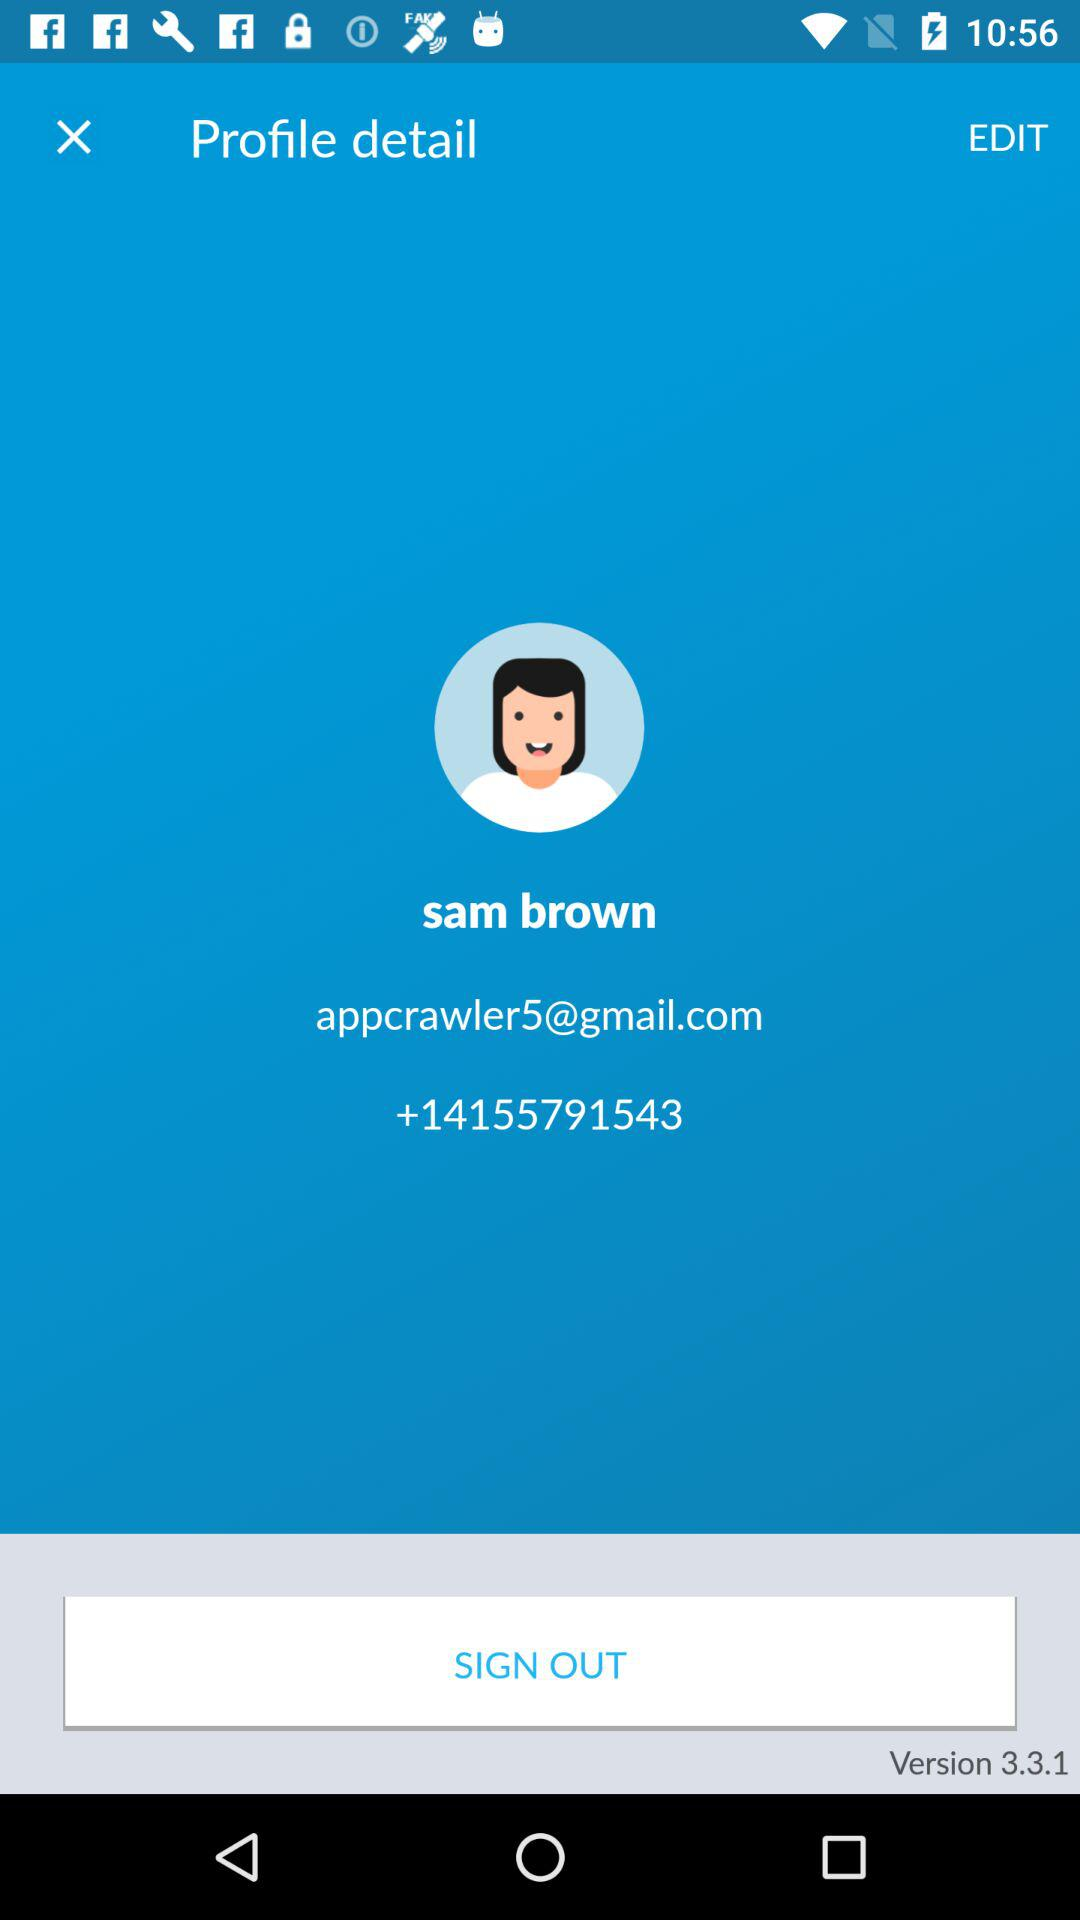What version of the app are we using? You are using version 3.3.1 of the app. 